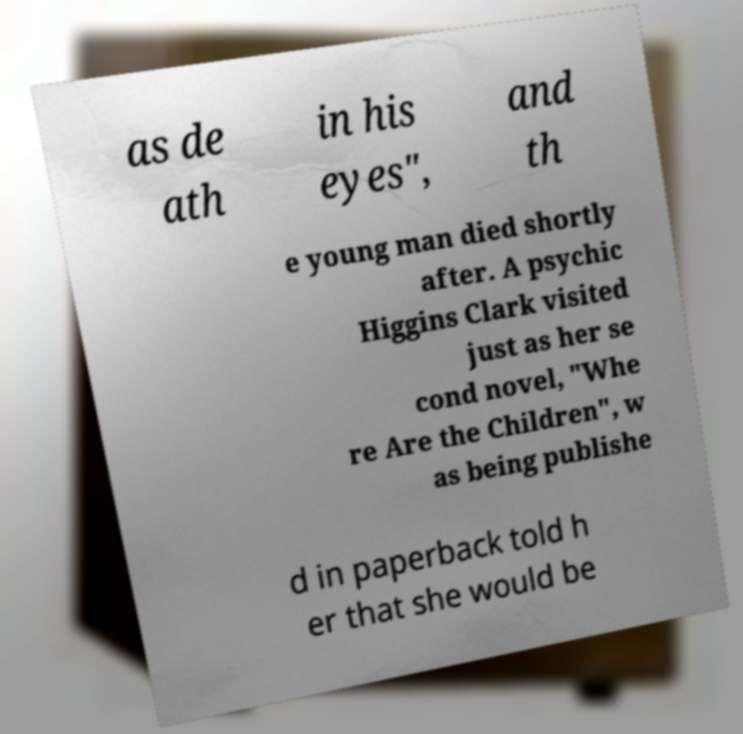I need the written content from this picture converted into text. Can you do that? as de ath in his eyes", and th e young man died shortly after. A psychic Higgins Clark visited just as her se cond novel, "Whe re Are the Children", w as being publishe d in paperback told h er that she would be 